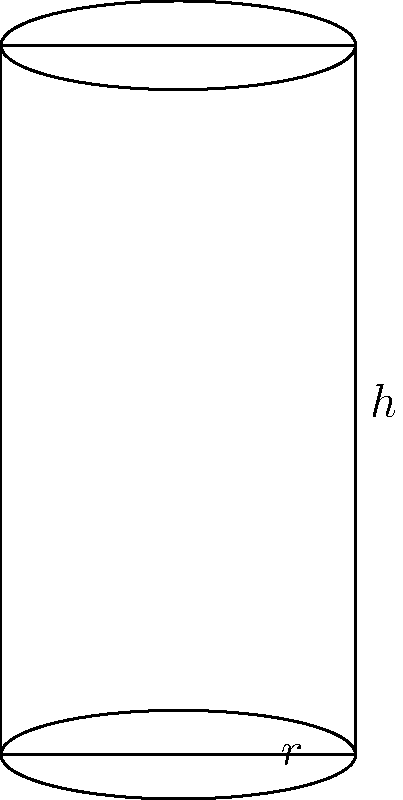As a professional classical piano player, you're interested in the craftsmanship of your instrument. The cylindrical legs of your grand piano contribute to its elegant design. If one leg has a radius of 5 cm and a height of 20 cm, what is the total surface area of the leg, including the top and bottom circular faces? Round your answer to the nearest square centimeter. To calculate the surface area of the cylindrical piano leg, we need to consider three components:

1. The curved lateral surface area
2. The area of the top circular face
3. The area of the bottom circular face

Let's solve this step by step:

1. Lateral surface area:
   The formula for the lateral surface area of a cylinder is $A_l = 2\pi rh$
   $A_l = 2\pi \cdot 5 \text{ cm} \cdot 20 \text{ cm} = 200\pi \text{ cm}^2$

2. Area of the top circular face:
   The formula for the area of a circle is $A_c = \pi r^2$
   $A_c = \pi \cdot (5 \text{ cm})^2 = 25\pi \text{ cm}^2$

3. Area of the bottom circular face:
   This is the same as the top face: $25\pi \text{ cm}^2$

Now, we sum up all three components:

Total surface area = Lateral surface area + Top face area + Bottom face area
$A_{\text{total}} = 200\pi \text{ cm}^2 + 25\pi \text{ cm}^2 + 25\pi \text{ cm}^2 = 250\pi \text{ cm}^2$

Converting to a numerical value:
$A_{\text{total}} = 250 \cdot 3.14159... \approx 785.40 \text{ cm}^2$

Rounding to the nearest square centimeter:
$A_{\text{total}} \approx 785 \text{ cm}^2$
Answer: 785 cm² 